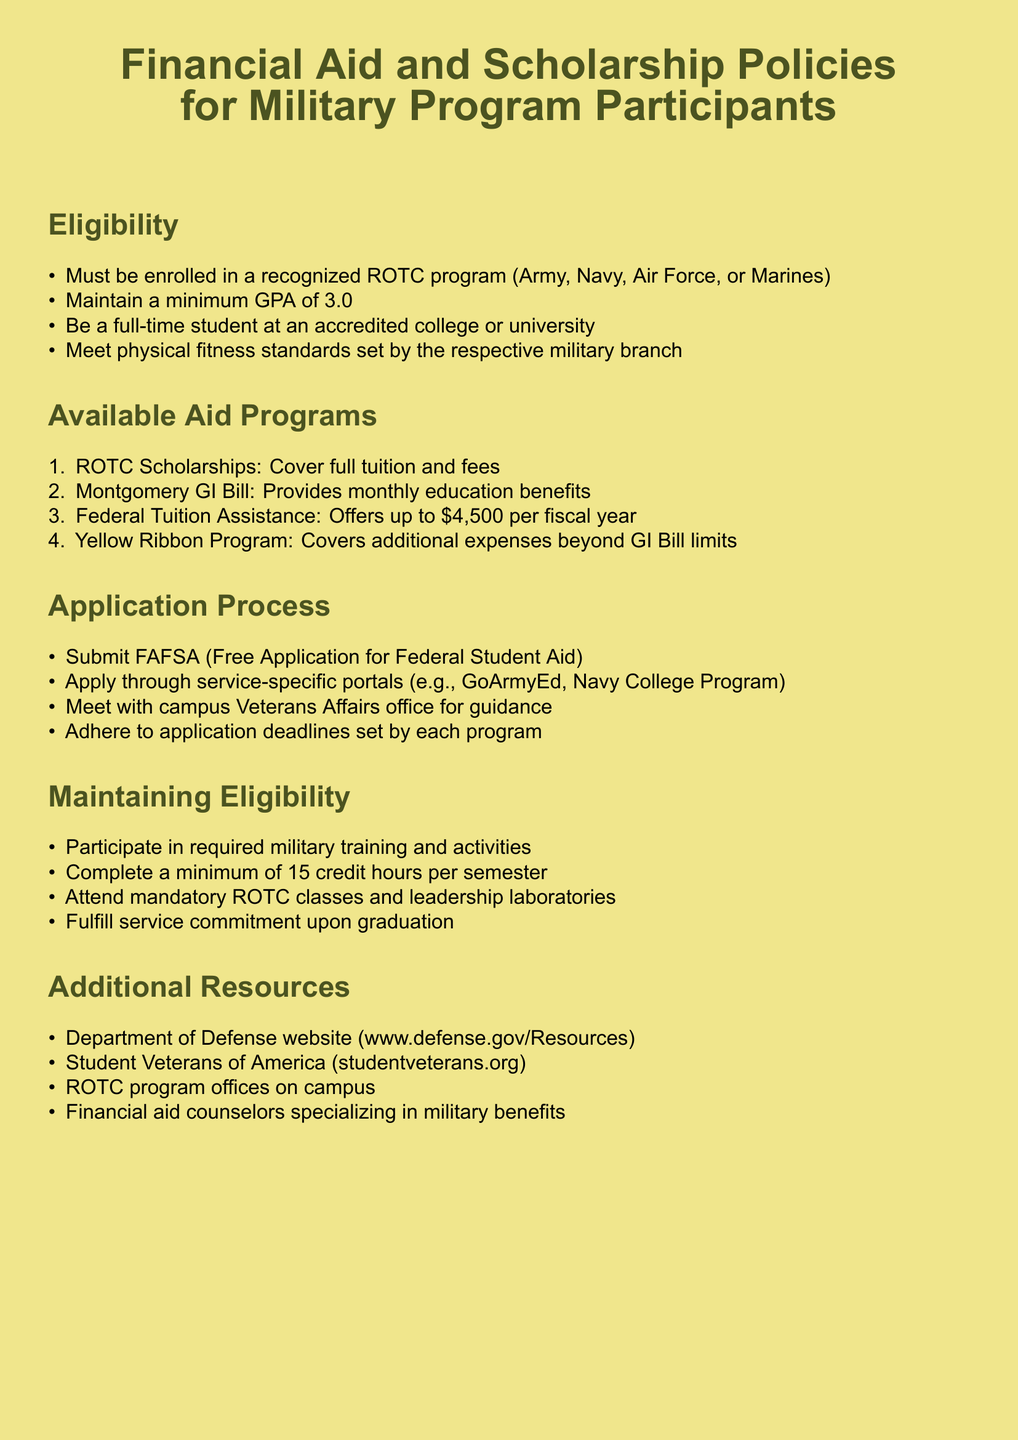What is the minimum GPA required for eligibility? The minimum GPA required for eligibility is stated in the "Eligibility" section, which outlines the necessary academic standard.
Answer: 3.0 What is the maximum amount provided by Federal Tuition Assistance per fiscal year? The maximum amount is mentioned in the "Available Aid Programs" section, specifically detailing the benefits offered.
Answer: $4,500 What must a participant fulfill upon graduation? The document specifies a requirement in the "Maintaining Eligibility" section, indicating a commitment that must be met after completion of the program.
Answer: Service commitment What is the first step in the application process for financial aid? The first step is outlined in the "Application Process" section, which lists the initial requirement for students seeking aid.
Answer: Submit FAFSA What resource provides guidance for military benefits? This information is found in the "Additional Resources" section, where support services for military participants are listed.
Answer: Financial aid counselors specializing in military benefits How many credit hours must be completed per semester? The requirement regarding credit hours is specified in the "Maintaining Eligibility" section, addressing academic progression for funding.
Answer: 15 credit hours Which program covers full tuition and fees? The specific program that covers full tuition and fees is included in the "Available Aid Programs" section, detailing assistance options available to participants.
Answer: ROTC Scholarships What website is mentioned for additional military resources? The document contains a specified resource in the "Additional Resources" section, directing participants to a relevant online platform.
Answer: www.defense.gov/Resources 